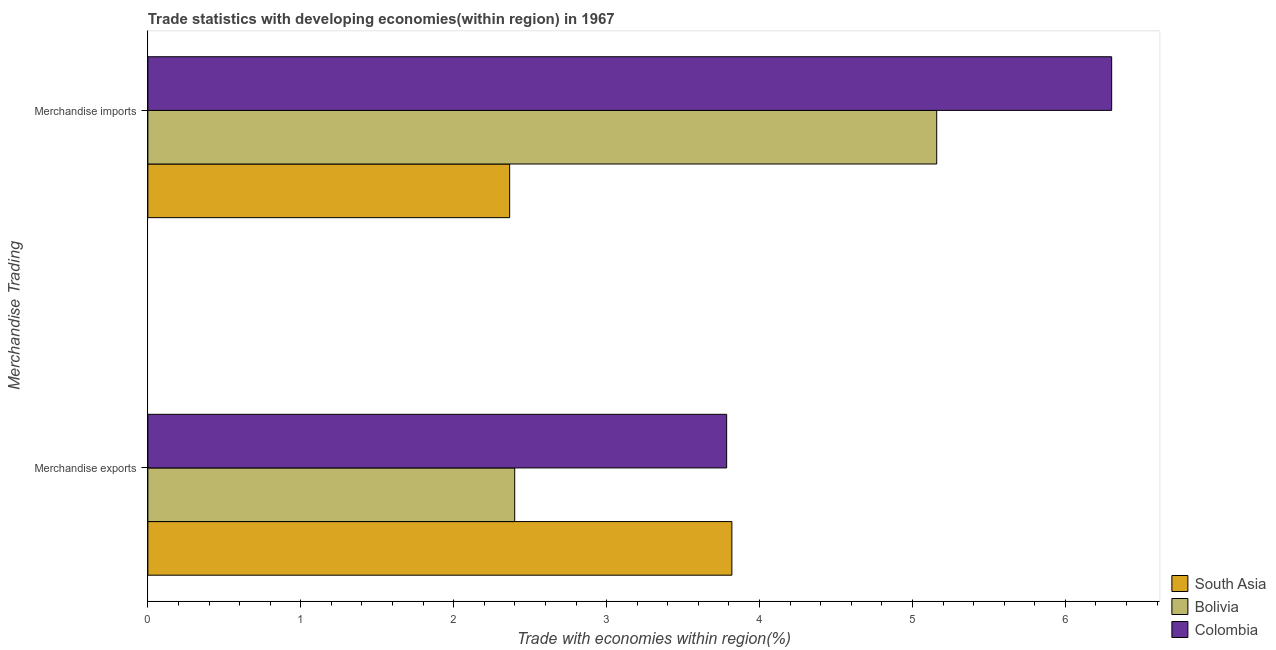Are the number of bars per tick equal to the number of legend labels?
Your answer should be compact. Yes. Are the number of bars on each tick of the Y-axis equal?
Keep it short and to the point. Yes. How many bars are there on the 2nd tick from the bottom?
Your answer should be compact. 3. What is the merchandise imports in Colombia?
Offer a terse response. 6.3. Across all countries, what is the maximum merchandise imports?
Keep it short and to the point. 6.3. Across all countries, what is the minimum merchandise exports?
Your answer should be very brief. 2.4. In which country was the merchandise imports minimum?
Keep it short and to the point. South Asia. What is the total merchandise imports in the graph?
Make the answer very short. 13.83. What is the difference between the merchandise exports in South Asia and that in Bolivia?
Your answer should be compact. 1.42. What is the difference between the merchandise exports in Colombia and the merchandise imports in Bolivia?
Make the answer very short. -1.37. What is the average merchandise imports per country?
Your answer should be compact. 4.61. What is the difference between the merchandise exports and merchandise imports in Colombia?
Make the answer very short. -2.52. In how many countries, is the merchandise imports greater than 6.4 %?
Your response must be concise. 0. What is the ratio of the merchandise imports in Bolivia to that in Colombia?
Provide a succinct answer. 0.82. Is the merchandise exports in Colombia less than that in Bolivia?
Offer a very short reply. No. In how many countries, is the merchandise imports greater than the average merchandise imports taken over all countries?
Your answer should be compact. 2. What does the 3rd bar from the top in Merchandise imports represents?
Give a very brief answer. South Asia. Are all the bars in the graph horizontal?
Give a very brief answer. Yes. What is the difference between two consecutive major ticks on the X-axis?
Provide a succinct answer. 1. Where does the legend appear in the graph?
Provide a short and direct response. Bottom right. How are the legend labels stacked?
Provide a succinct answer. Vertical. What is the title of the graph?
Offer a very short reply. Trade statistics with developing economies(within region) in 1967. What is the label or title of the X-axis?
Ensure brevity in your answer.  Trade with economies within region(%). What is the label or title of the Y-axis?
Offer a very short reply. Merchandise Trading. What is the Trade with economies within region(%) of South Asia in Merchandise exports?
Provide a short and direct response. 3.82. What is the Trade with economies within region(%) in Bolivia in Merchandise exports?
Your response must be concise. 2.4. What is the Trade with economies within region(%) in Colombia in Merchandise exports?
Your answer should be compact. 3.79. What is the Trade with economies within region(%) in South Asia in Merchandise imports?
Offer a terse response. 2.37. What is the Trade with economies within region(%) in Bolivia in Merchandise imports?
Provide a succinct answer. 5.16. What is the Trade with economies within region(%) of Colombia in Merchandise imports?
Your answer should be very brief. 6.3. Across all Merchandise Trading, what is the maximum Trade with economies within region(%) in South Asia?
Offer a terse response. 3.82. Across all Merchandise Trading, what is the maximum Trade with economies within region(%) in Bolivia?
Offer a very short reply. 5.16. Across all Merchandise Trading, what is the maximum Trade with economies within region(%) of Colombia?
Keep it short and to the point. 6.3. Across all Merchandise Trading, what is the minimum Trade with economies within region(%) of South Asia?
Your answer should be very brief. 2.37. Across all Merchandise Trading, what is the minimum Trade with economies within region(%) of Bolivia?
Your response must be concise. 2.4. Across all Merchandise Trading, what is the minimum Trade with economies within region(%) in Colombia?
Ensure brevity in your answer.  3.79. What is the total Trade with economies within region(%) of South Asia in the graph?
Keep it short and to the point. 6.18. What is the total Trade with economies within region(%) of Bolivia in the graph?
Make the answer very short. 7.56. What is the total Trade with economies within region(%) in Colombia in the graph?
Offer a terse response. 10.09. What is the difference between the Trade with economies within region(%) of South Asia in Merchandise exports and that in Merchandise imports?
Keep it short and to the point. 1.45. What is the difference between the Trade with economies within region(%) of Bolivia in Merchandise exports and that in Merchandise imports?
Keep it short and to the point. -2.76. What is the difference between the Trade with economies within region(%) in Colombia in Merchandise exports and that in Merchandise imports?
Keep it short and to the point. -2.52. What is the difference between the Trade with economies within region(%) in South Asia in Merchandise exports and the Trade with economies within region(%) in Bolivia in Merchandise imports?
Your response must be concise. -1.34. What is the difference between the Trade with economies within region(%) of South Asia in Merchandise exports and the Trade with economies within region(%) of Colombia in Merchandise imports?
Keep it short and to the point. -2.48. What is the difference between the Trade with economies within region(%) in Bolivia in Merchandise exports and the Trade with economies within region(%) in Colombia in Merchandise imports?
Your response must be concise. -3.9. What is the average Trade with economies within region(%) of South Asia per Merchandise Trading?
Offer a terse response. 3.09. What is the average Trade with economies within region(%) of Bolivia per Merchandise Trading?
Keep it short and to the point. 3.78. What is the average Trade with economies within region(%) in Colombia per Merchandise Trading?
Ensure brevity in your answer.  5.04. What is the difference between the Trade with economies within region(%) in South Asia and Trade with economies within region(%) in Bolivia in Merchandise exports?
Your response must be concise. 1.42. What is the difference between the Trade with economies within region(%) of South Asia and Trade with economies within region(%) of Colombia in Merchandise exports?
Provide a short and direct response. 0.03. What is the difference between the Trade with economies within region(%) in Bolivia and Trade with economies within region(%) in Colombia in Merchandise exports?
Offer a very short reply. -1.39. What is the difference between the Trade with economies within region(%) in South Asia and Trade with economies within region(%) in Bolivia in Merchandise imports?
Offer a terse response. -2.79. What is the difference between the Trade with economies within region(%) of South Asia and Trade with economies within region(%) of Colombia in Merchandise imports?
Offer a terse response. -3.94. What is the difference between the Trade with economies within region(%) of Bolivia and Trade with economies within region(%) of Colombia in Merchandise imports?
Provide a short and direct response. -1.14. What is the ratio of the Trade with economies within region(%) of South Asia in Merchandise exports to that in Merchandise imports?
Your answer should be compact. 1.61. What is the ratio of the Trade with economies within region(%) in Bolivia in Merchandise exports to that in Merchandise imports?
Keep it short and to the point. 0.47. What is the ratio of the Trade with economies within region(%) of Colombia in Merchandise exports to that in Merchandise imports?
Ensure brevity in your answer.  0.6. What is the difference between the highest and the second highest Trade with economies within region(%) of South Asia?
Offer a very short reply. 1.45. What is the difference between the highest and the second highest Trade with economies within region(%) in Bolivia?
Make the answer very short. 2.76. What is the difference between the highest and the second highest Trade with economies within region(%) of Colombia?
Provide a short and direct response. 2.52. What is the difference between the highest and the lowest Trade with economies within region(%) of South Asia?
Give a very brief answer. 1.45. What is the difference between the highest and the lowest Trade with economies within region(%) of Bolivia?
Your response must be concise. 2.76. What is the difference between the highest and the lowest Trade with economies within region(%) in Colombia?
Your response must be concise. 2.52. 